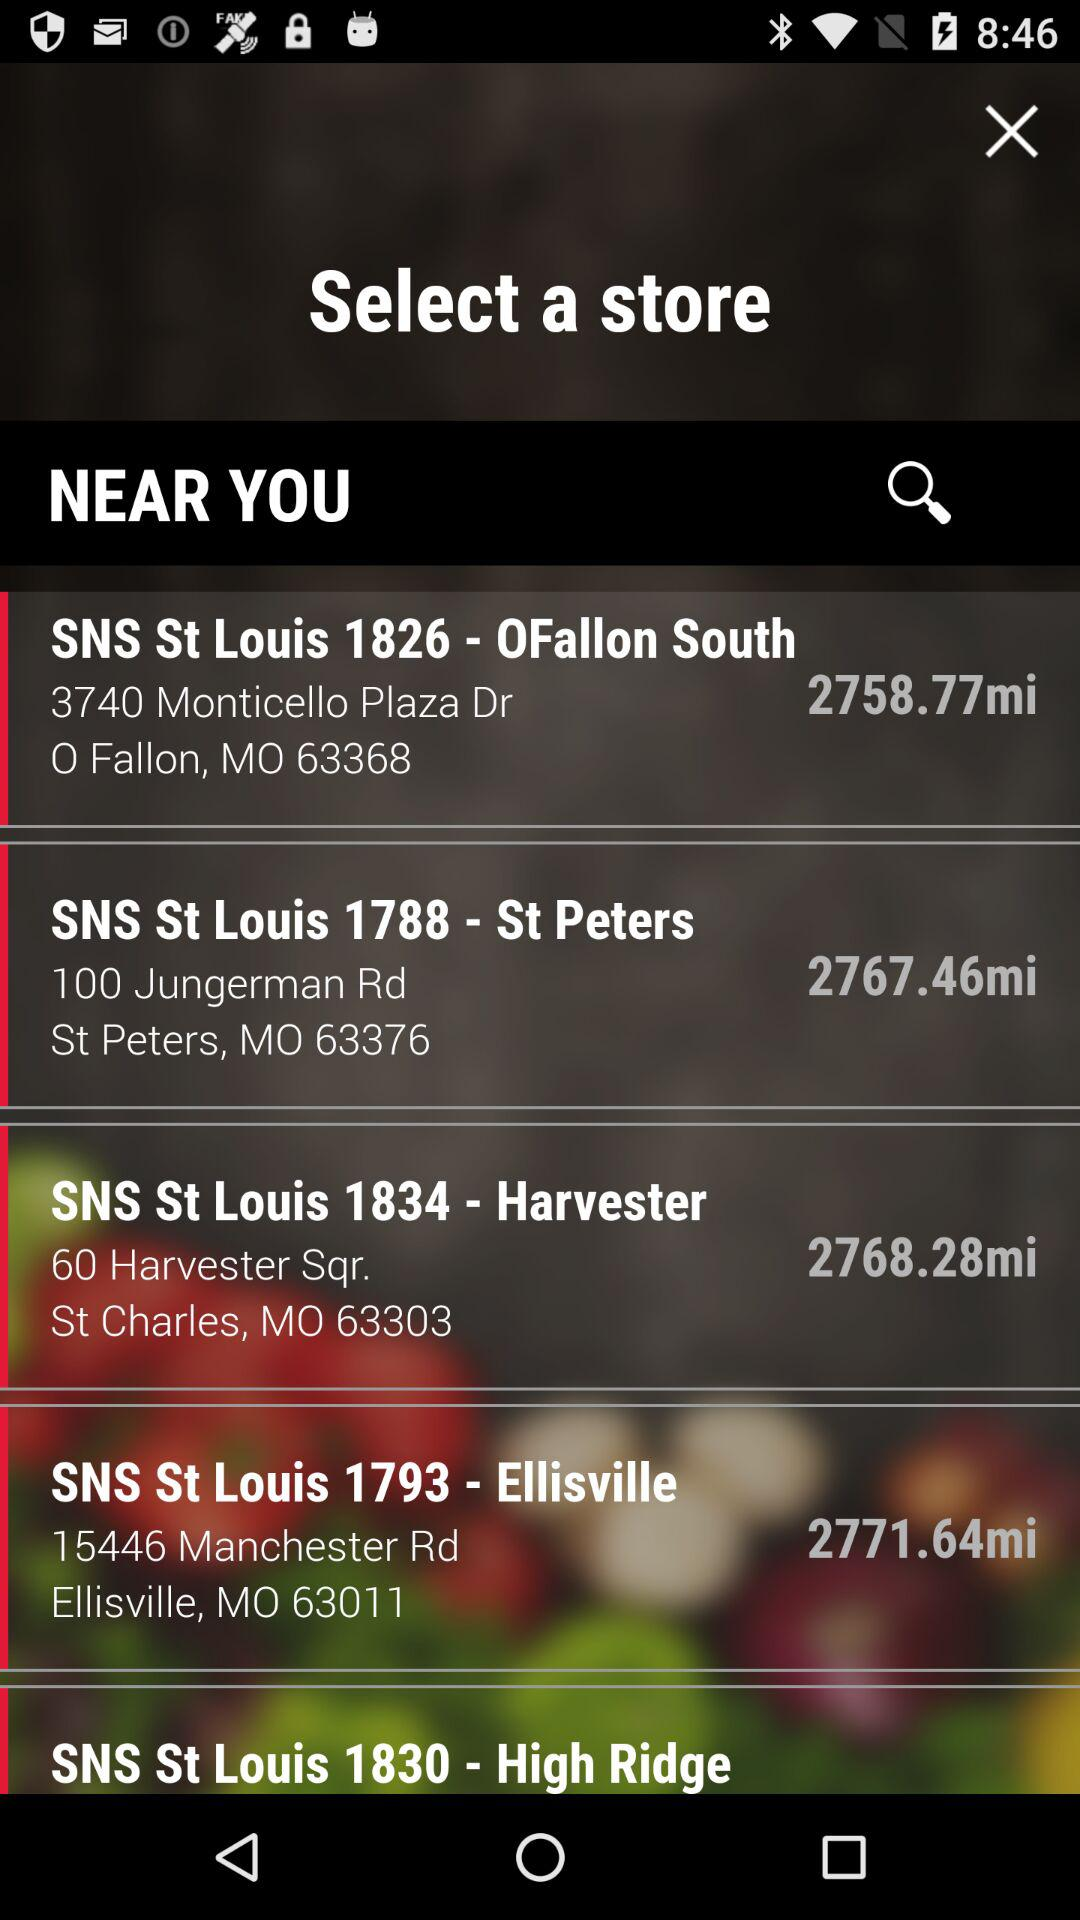What are the stores near me? The stores that are near me are "SNS St Louis 1826 - 0Fallon South", "SNS St Louis 1788 - St Peters", "SNS St Louis 1834 - Harvester", "SNS St Louis 1793 - Ellisville" and "SNS St Louis 1830 - High Ridge". 